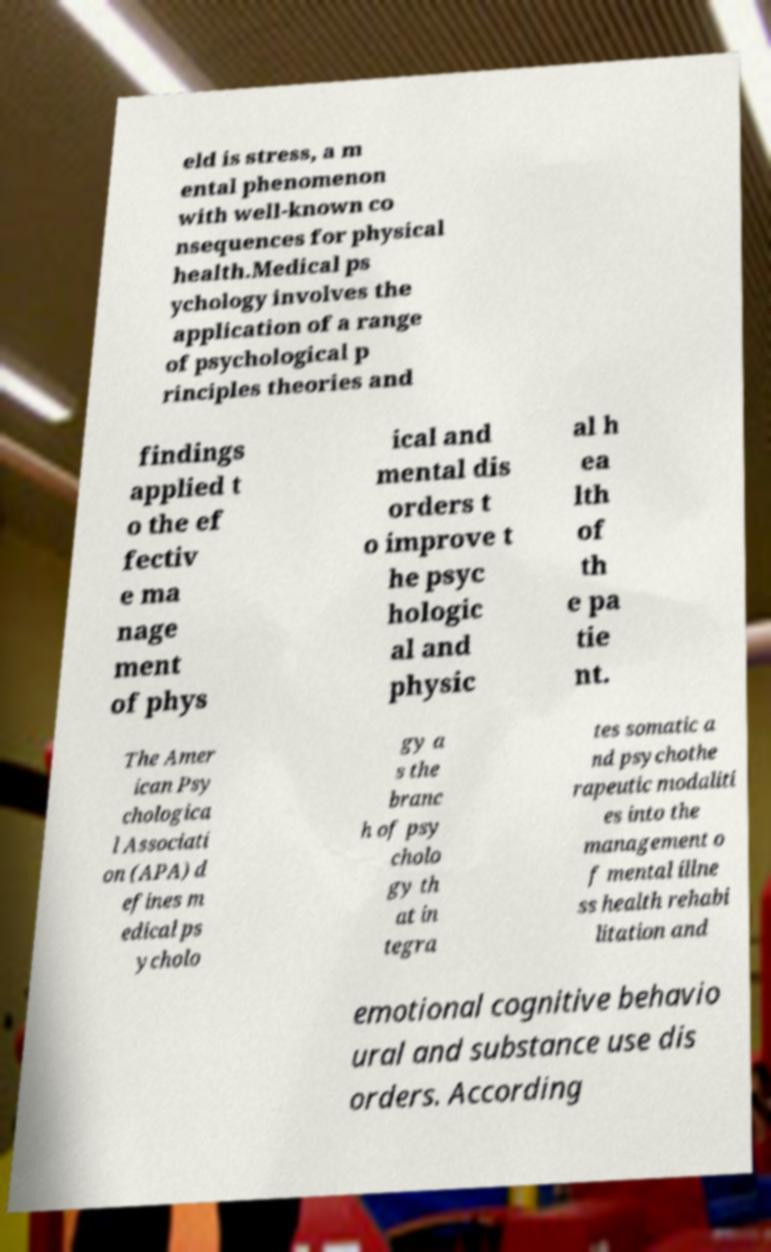Could you assist in decoding the text presented in this image and type it out clearly? eld is stress, a m ental phenomenon with well-known co nsequences for physical health.Medical ps ychology involves the application of a range of psychological p rinciples theories and findings applied t o the ef fectiv e ma nage ment of phys ical and mental dis orders t o improve t he psyc hologic al and physic al h ea lth of th e pa tie nt. The Amer ican Psy chologica l Associati on (APA) d efines m edical ps ycholo gy a s the branc h of psy cholo gy th at in tegra tes somatic a nd psychothe rapeutic modaliti es into the management o f mental illne ss health rehabi litation and emotional cognitive behavio ural and substance use dis orders. According 